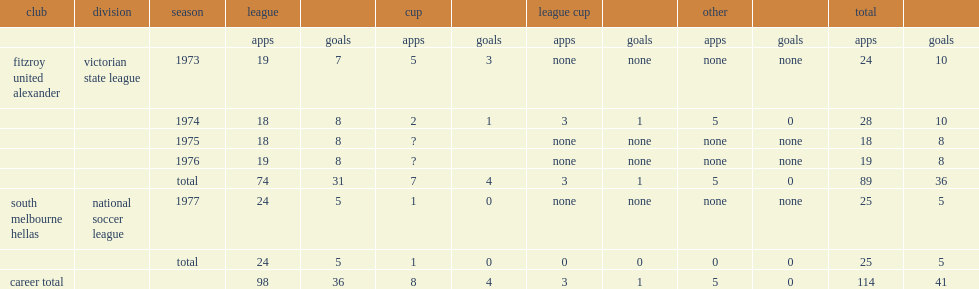Which club did gibson play for in 1977? South melbourne hellas. 